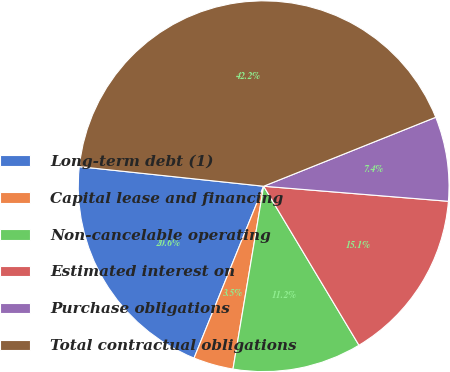Convert chart to OTSL. <chart><loc_0><loc_0><loc_500><loc_500><pie_chart><fcel>Long-term debt (1)<fcel>Capital lease and financing<fcel>Non-cancelable operating<fcel>Estimated interest on<fcel>Purchase obligations<fcel>Total contractual obligations<nl><fcel>20.56%<fcel>3.48%<fcel>11.24%<fcel>15.11%<fcel>7.36%<fcel>42.25%<nl></chart> 